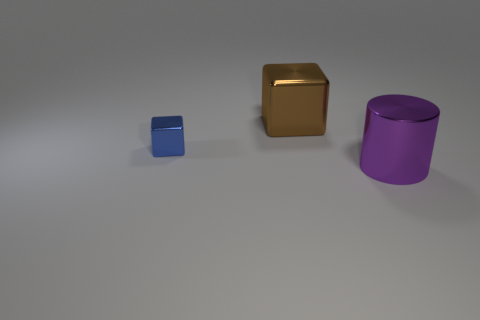There is a large object on the left side of the thing that is right of the brown metal block; what is it made of?
Offer a terse response. Metal. What number of cubes are in front of the big metal cylinder in front of the big shiny object that is behind the small blue metal object?
Offer a very short reply. 0. Do the cube in front of the big brown object and the large object that is in front of the tiny blue thing have the same material?
Offer a very short reply. Yes. What number of large things are the same shape as the small metallic object?
Offer a terse response. 1. Are there more metal things that are left of the blue thing than tiny blue metal things?
Make the answer very short. No. There is a big metallic thing on the left side of the large thing right of the shiny block to the right of the blue metal block; what shape is it?
Offer a terse response. Cube. There is a thing on the right side of the brown metal object; is it the same shape as the large thing on the left side of the purple thing?
Provide a succinct answer. No. Is there anything else that is the same size as the purple metallic cylinder?
Your answer should be very brief. Yes. What number of cylinders are either blue things or big blue things?
Your response must be concise. 0. Is the material of the small blue block the same as the purple cylinder?
Make the answer very short. Yes. 